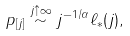<formula> <loc_0><loc_0><loc_500><loc_500>p _ { [ j ] } \stackrel { j \uparrow \infty } { \sim } j ^ { - 1 / \alpha } \ell _ { * } ( j ) ,</formula> 